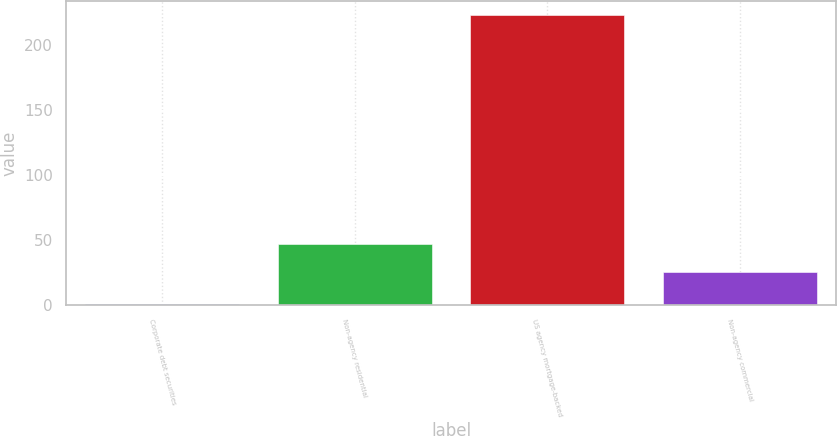<chart> <loc_0><loc_0><loc_500><loc_500><bar_chart><fcel>Corporate debt securities<fcel>Non-agency residential<fcel>US agency mortgage-backed<fcel>Non-agency commercial<nl><fcel>1<fcel>47.2<fcel>223<fcel>25<nl></chart> 